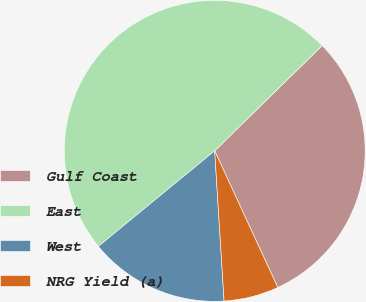Convert chart to OTSL. <chart><loc_0><loc_0><loc_500><loc_500><pie_chart><fcel>Gulf Coast<fcel>East<fcel>West<fcel>NRG Yield (a)<nl><fcel>30.45%<fcel>48.61%<fcel>15.05%<fcel>5.89%<nl></chart> 